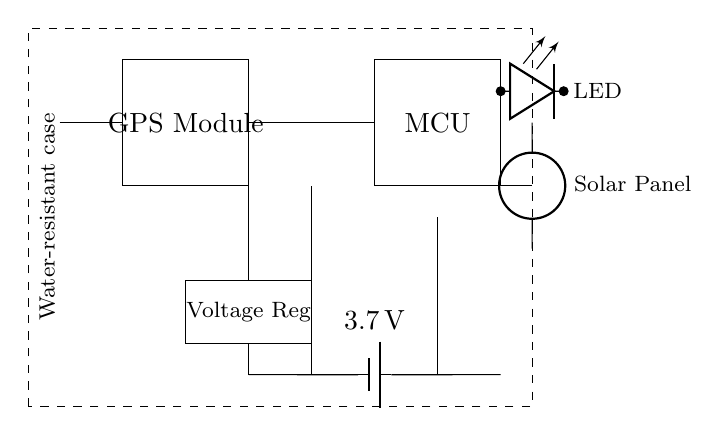What component provides power to the circuit? The circuit diagram shows a battery labeled with a voltage of 3.7 volts, which supplies power to the entire circuit.
Answer: battery What is the main function of the GPS module? The GPS module is responsible for receiving signals from satellites to determine location coordinates, making it essential for tracking purposes.
Answer: location tracking What does the dashed rectangle represent? The dashed rectangle in the circuit diagram indicates the presence of a water-resistant case, which protects the internal components from moisture and environmental damage.
Answer: water-resistant case How many volts does the voltage regulator output? The voltage regulator is connected between the battery and the microcontroller, ensuring a stable output voltage. In this case, the exact output voltage is not specified, but it typically would be set to match the needs of the microcontroller.
Answer: undefined (typically 3.3V or 5V) What is the purpose of the LED indicator? The LED indicator is connected to show the operational status of the device, usually indicating when the device is turned on or is actively tracking its location.
Answer: operational status What type of power source is shown in this circuit? A solar panel is illustrated in the diagram, which acts as a renewable energy source, supplementing the battery to keep the device charged during outdoor adventures.
Answer: solar panel How does the antenna contribute to the GPS functionality? The antenna is crucial for the GPS module, as it receives satellite signals, allowing the module to calculate its location accurately; thus, it is key for effective operation of the GPS function.
Answer: signal reception 